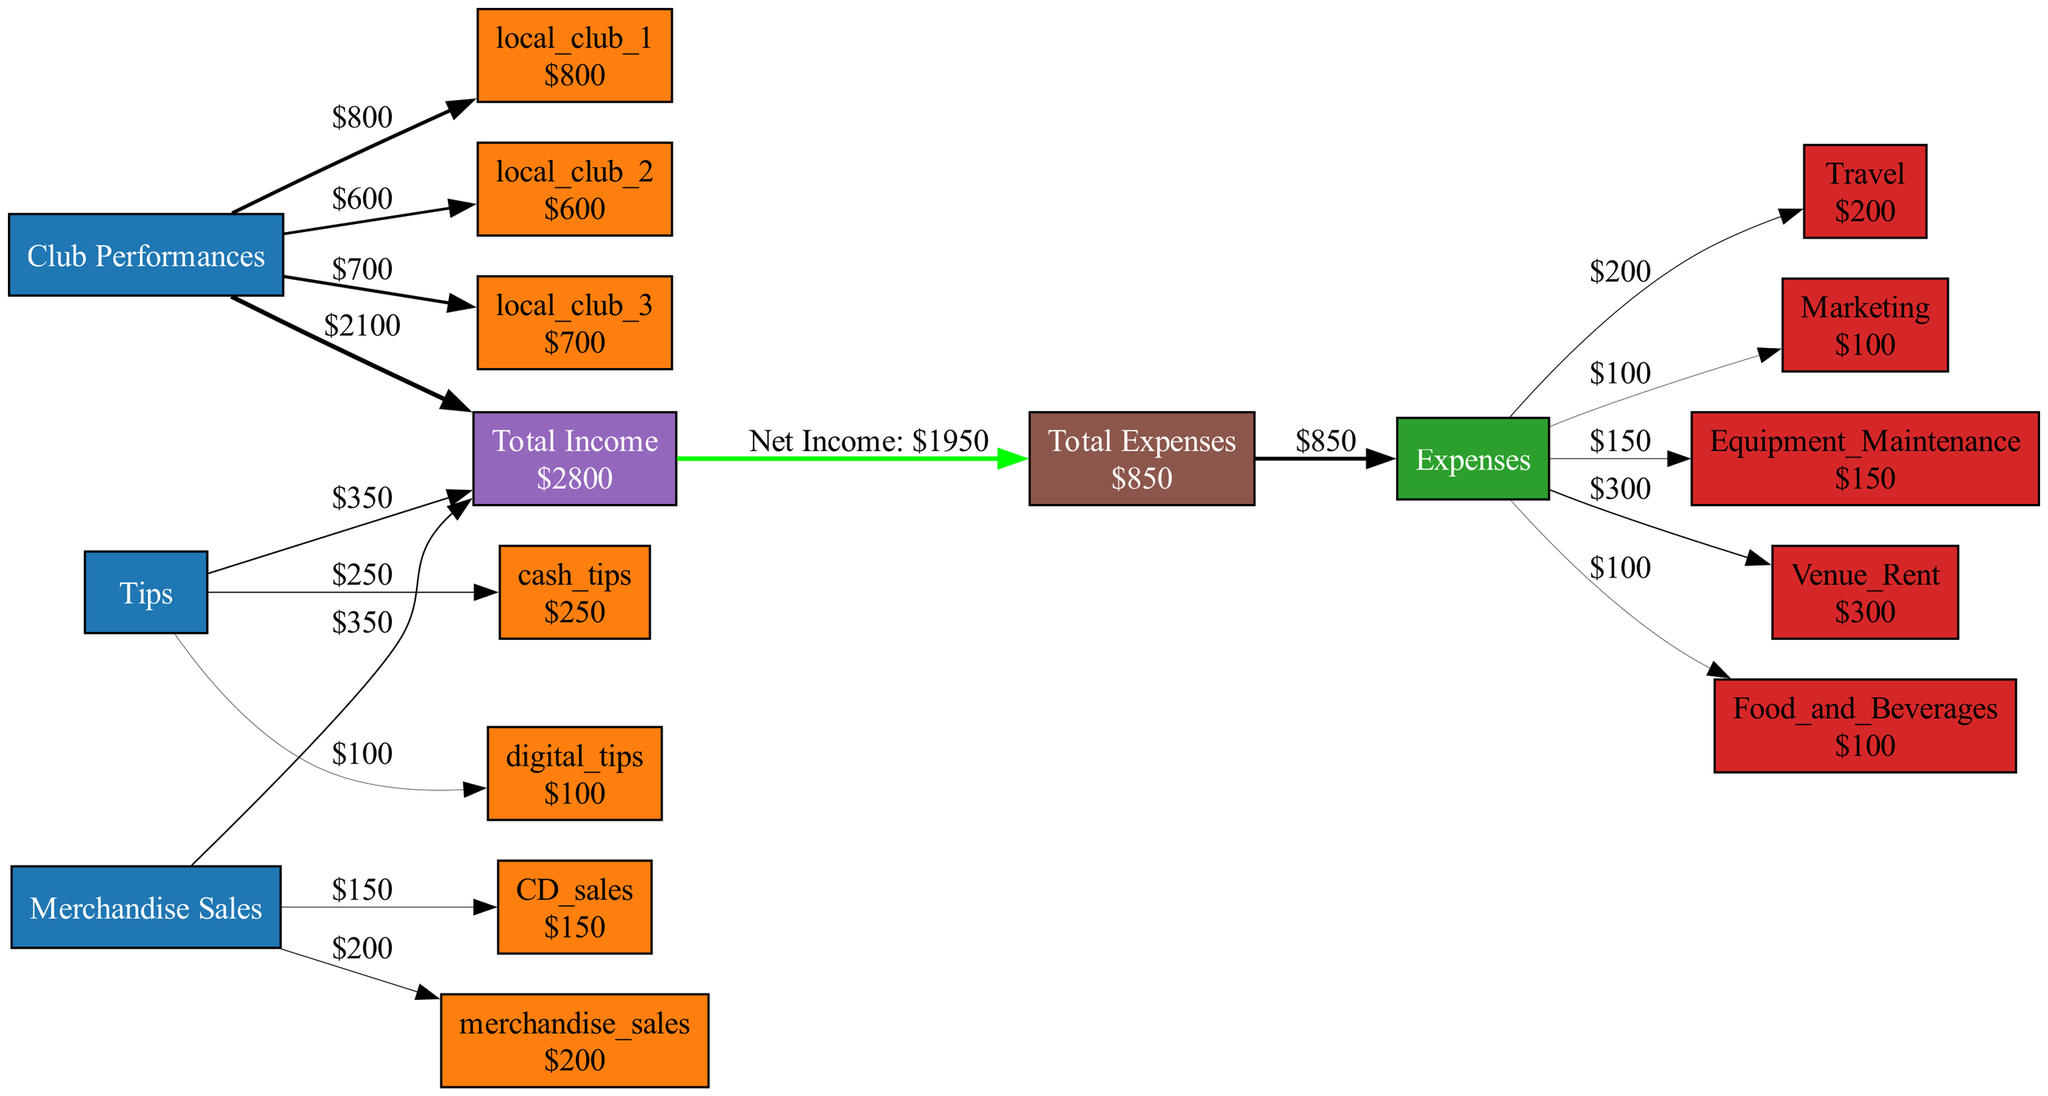What is the total income from Club Performances? The diagram shows three local clubs with specific income amounts: local_club_1 has 800, local_club_2 has 600, and local_club_3 has 700. Adding these amounts gives total income from club performances: 800 + 600 + 700 = 2100.
Answer: 2100 How much is earned from Tips? The diagram includes cash tips of 250 and digital tips of 100. Summing these amounts yields the total from tips: 250 + 100 = 350.
Answer: 350 What is the total amount spent on Equipment Maintenance? The diagram clearly labels Equipment Maintenance. The specific amount shown is 150. Therefore, the total spent on Equipment Maintenance is 150.
Answer: 150 What are the total expenses? The diagram lists multiple expenses: Travel 200, Marketing 100, Equipment Maintenance 150, Venue Rent 300, and Food and Beverages 100. Summing these amounts gives: 200 + 100 + 150 + 300 + 100 = 850.
Answer: 850 What is the net income after expenses? To find net income, we first calculate total income, which is 2600 (from adding all income sources) and total expenses of 850 (as calculated earlier). Net income is total income minus total expenses: 2600 - 850 = 1750.
Answer: 1750 How many sources of income are there? The diagram displays three main categories of income: Club Performances, Tips, and Merchandise Sales. Within these categories, there are multiple subcategories. However, main categories count as sources of income: hence there are three sources.
Answer: 3 Which income source has the highest subcategory? By examining the subcategories within each income source, we see that local_club_1 has 800, which is the highest amount compared to any other subcategory. Thus, the income source with the highest subcategory is Club Performances.
Answer: Club Performances What is the value of cash tips? The diagram specifies the cash tips amount as 250. This can be located under the Tips section of the diagram.
Answer: 250 How much is spent on Venue Rent? The diagram displays Venue Rent cost as 300, which is directly indicated in the expenses section. Hence, this is the total spent on Venue Rent.
Answer: 300 